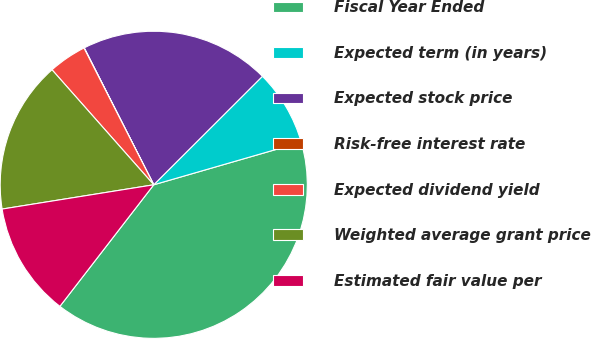<chart> <loc_0><loc_0><loc_500><loc_500><pie_chart><fcel>Fiscal Year Ended<fcel>Expected term (in years)<fcel>Expected stock price<fcel>Risk-free interest rate<fcel>Expected dividend yield<fcel>Weighted average grant price<fcel>Estimated fair value per<nl><fcel>39.94%<fcel>8.01%<fcel>19.99%<fcel>0.03%<fcel>4.02%<fcel>16.0%<fcel>12.01%<nl></chart> 